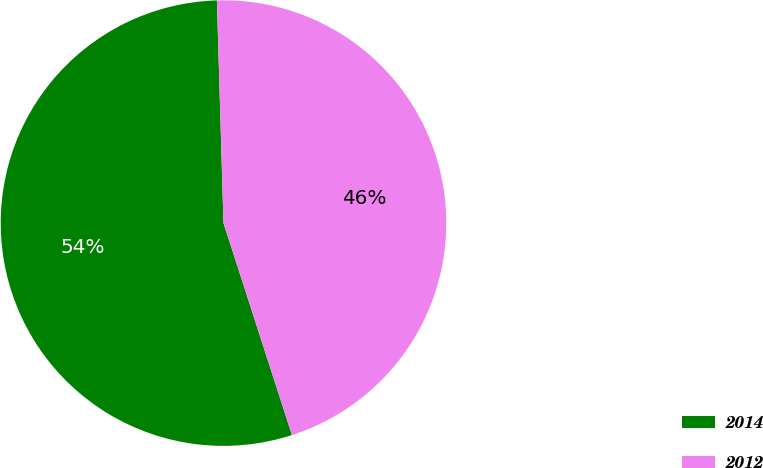Convert chart to OTSL. <chart><loc_0><loc_0><loc_500><loc_500><pie_chart><fcel>2014<fcel>2012<nl><fcel>54.5%<fcel>45.5%<nl></chart> 